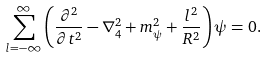<formula> <loc_0><loc_0><loc_500><loc_500>\sum _ { l = - \infty } ^ { \infty } \left ( \frac { \partial ^ { 2 } } { \partial t ^ { 2 } } - \nabla _ { 4 } ^ { 2 } + m _ { \psi } ^ { 2 } + \frac { l ^ { 2 } } { R ^ { 2 } } \right ) \psi = 0 .</formula> 